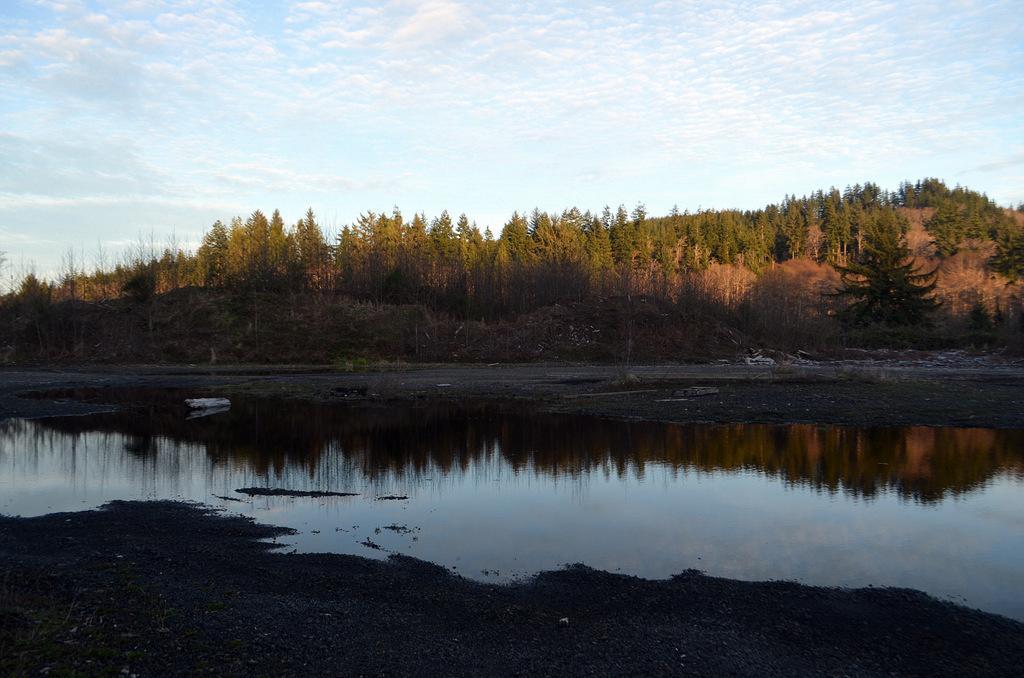Please provide a concise description of this image. In this picture I can see the water in the foreground. I can see trees in the background. I can see clouds in the sky. 